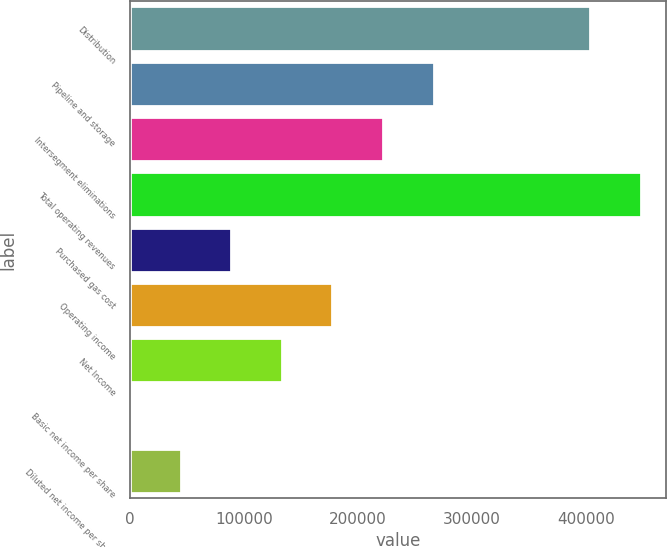Convert chart. <chart><loc_0><loc_0><loc_500><loc_500><bar_chart><fcel>Distribution<fcel>Pipeline and storage<fcel>Intersegment eliminations<fcel>Total operating revenues<fcel>Purchased gas cost<fcel>Operating income<fcel>Net Income<fcel>Basic net income per share<fcel>Diluted net income per share<nl><fcel>403793<fcel>266210<fcel>221842<fcel>448161<fcel>88737<fcel>177473<fcel>133105<fcel>0.49<fcel>44368.7<nl></chart> 